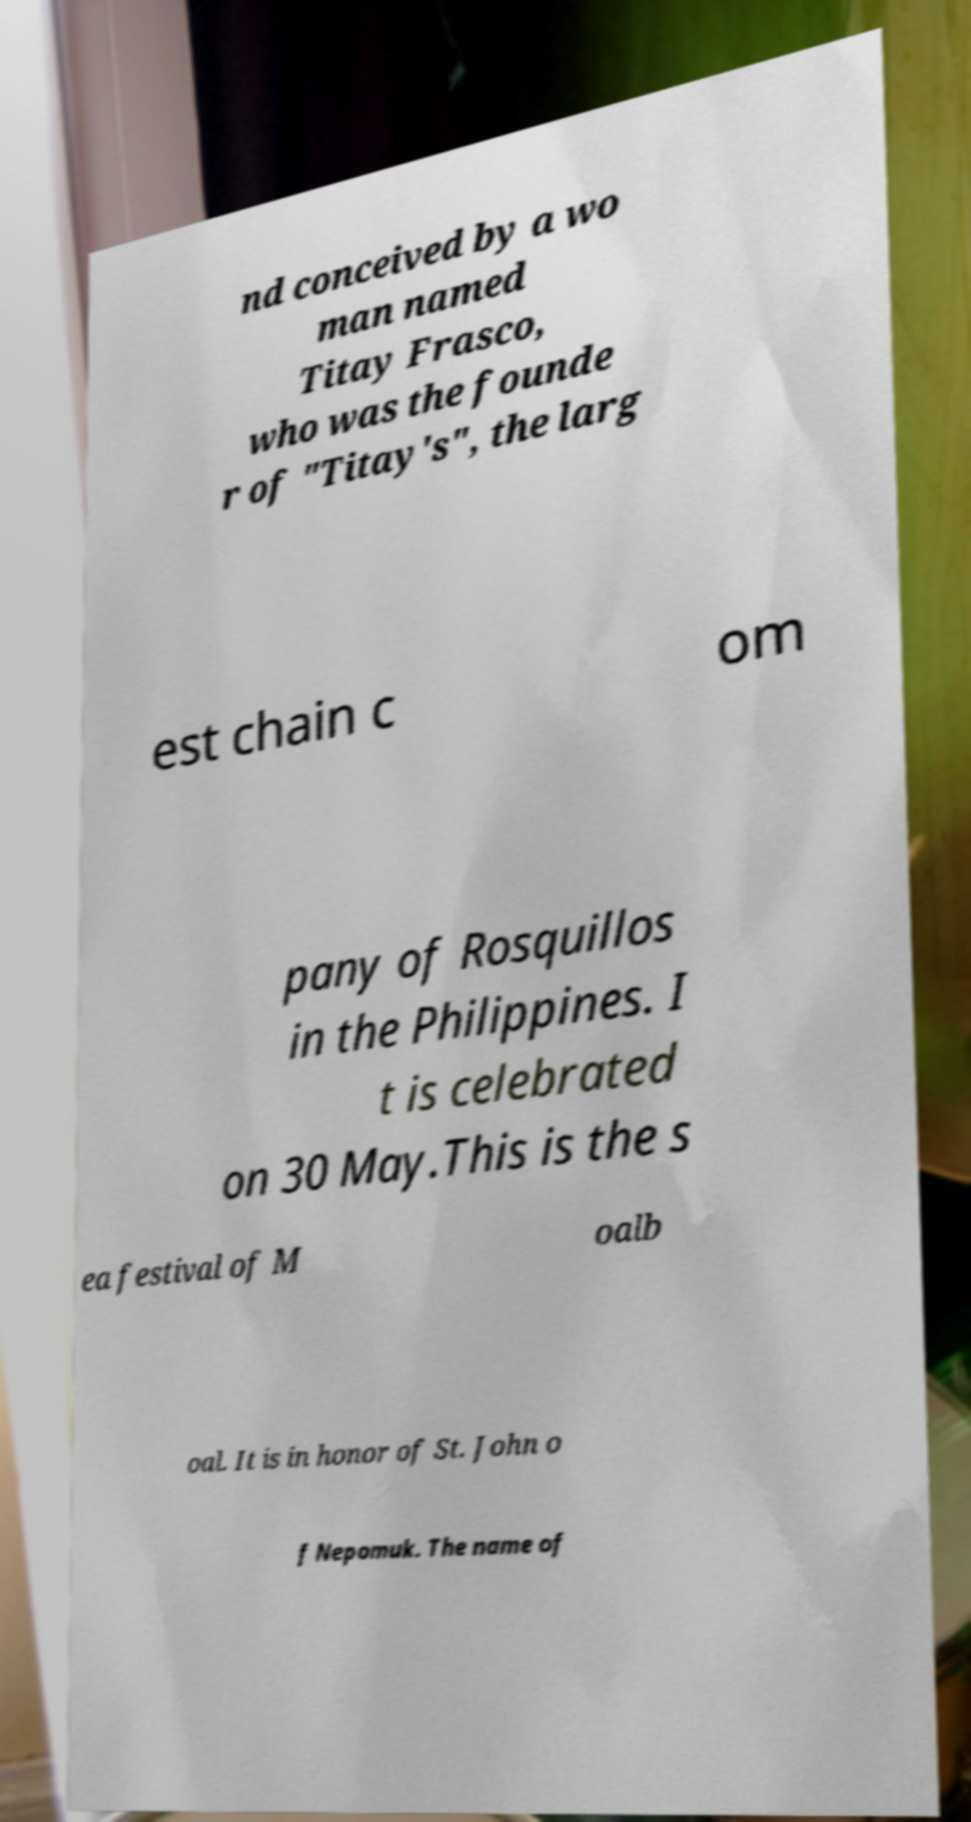What messages or text are displayed in this image? I need them in a readable, typed format. nd conceived by a wo man named Titay Frasco, who was the founde r of "Titay's", the larg est chain c om pany of Rosquillos in the Philippines. I t is celebrated on 30 May.This is the s ea festival of M oalb oal. It is in honor of St. John o f Nepomuk. The name of 